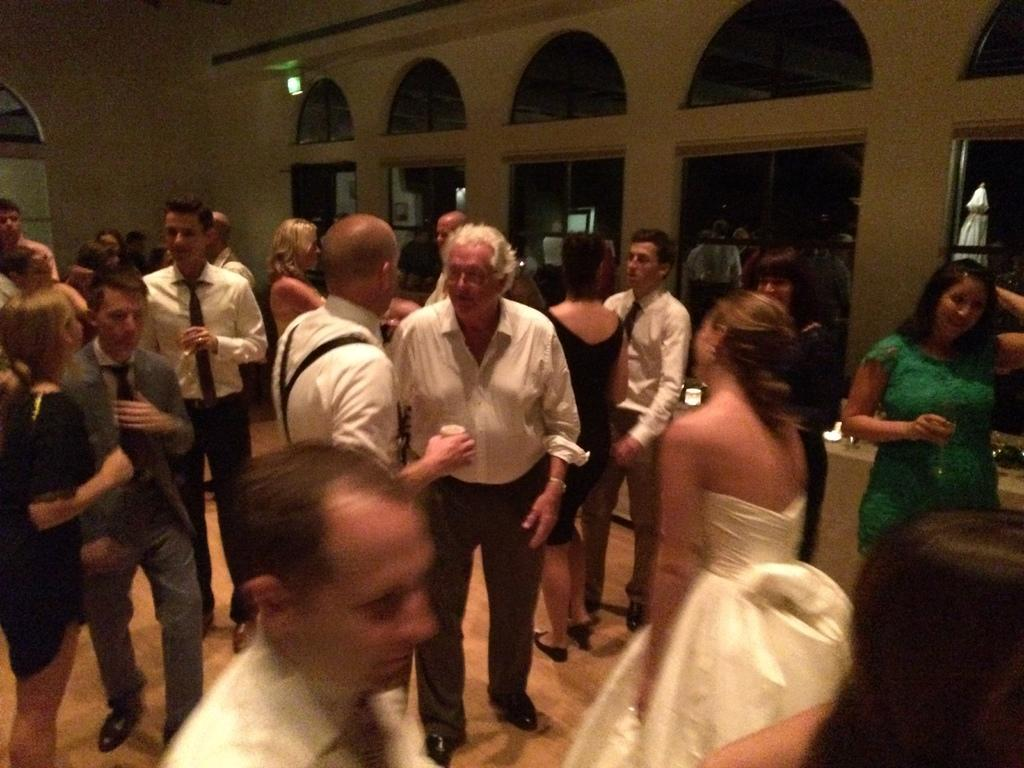What can be seen in the image? There are people standing in the image. Where are the people standing? The people are standing on the floor. What can be seen in the background of the image? There are windows and a wall in the background of the image. What type of amusement can be seen in the image? There is no amusement present in the image; it features people standing on the floor with a background of windows and a wall. What drug is being used by the people in the image? There is no drug use depicted in the image; it simply shows people standing on the floor. 